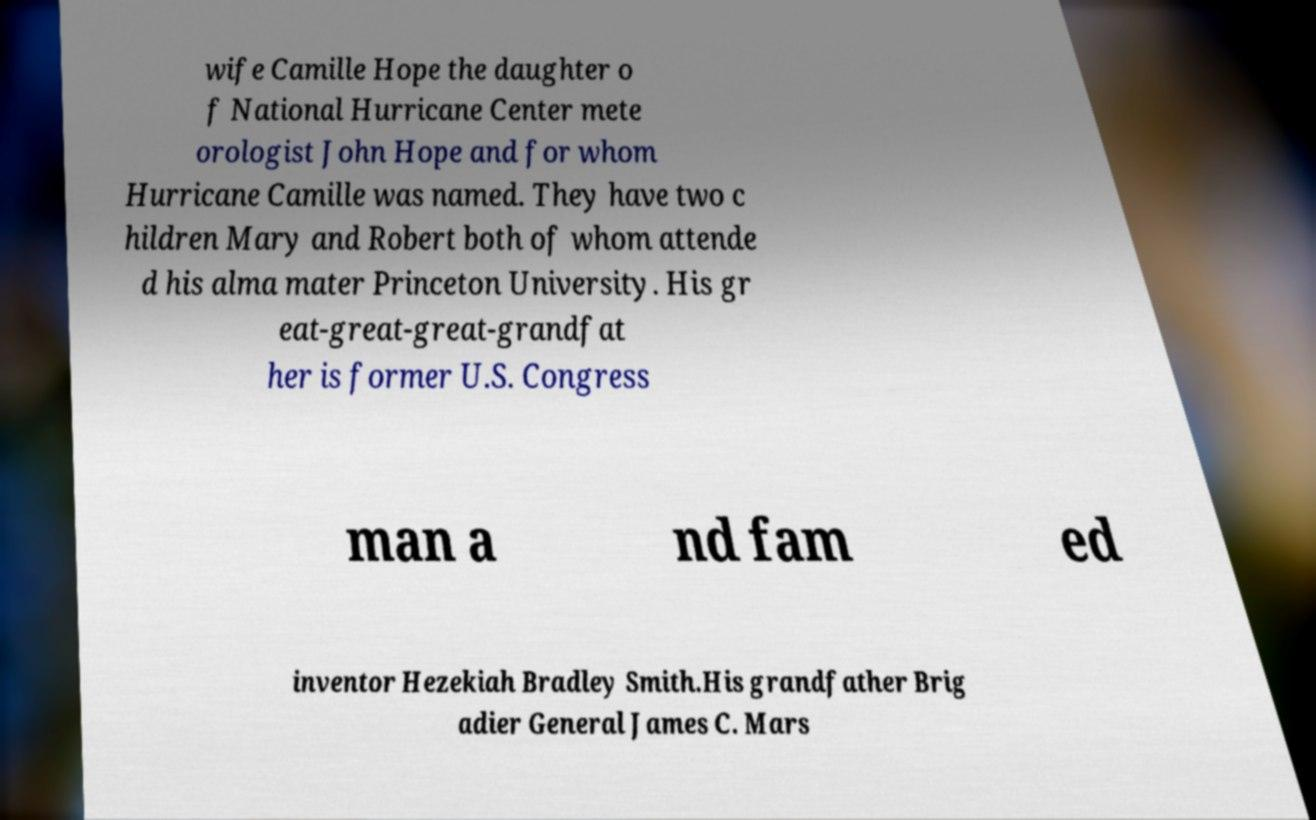I need the written content from this picture converted into text. Can you do that? wife Camille Hope the daughter o f National Hurricane Center mete orologist John Hope and for whom Hurricane Camille was named. They have two c hildren Mary and Robert both of whom attende d his alma mater Princeton University. His gr eat-great-great-grandfat her is former U.S. Congress man a nd fam ed inventor Hezekiah Bradley Smith.His grandfather Brig adier General James C. Mars 